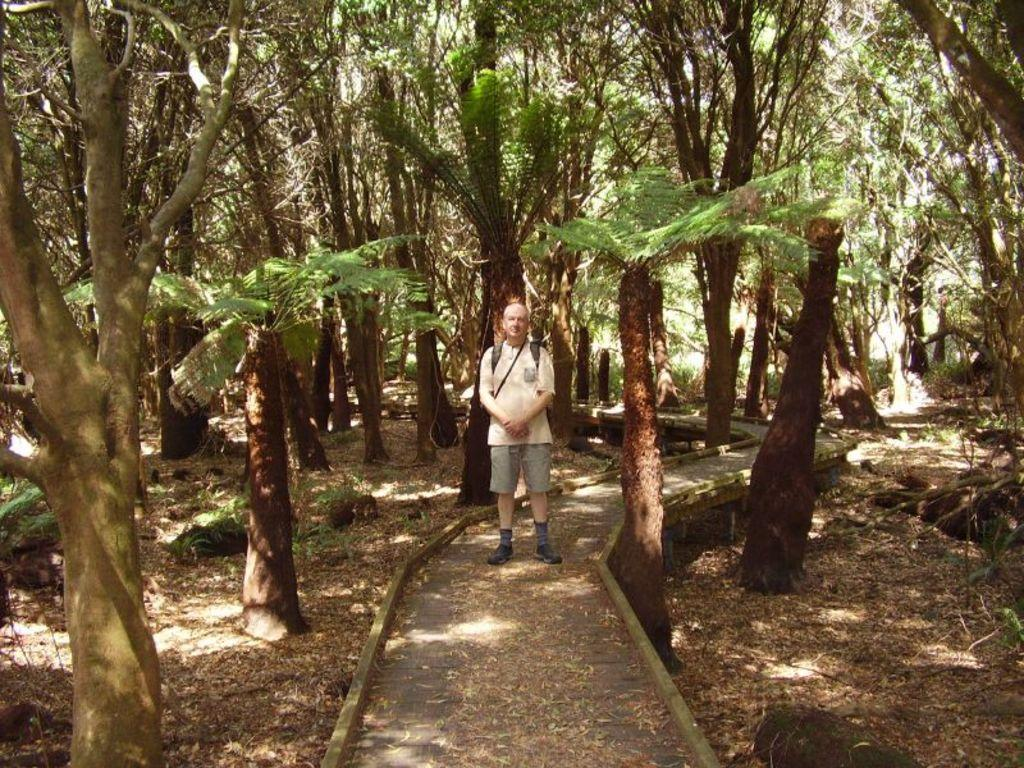Who is the main subject in the image? There is a man standing in the center of the image. Where is the man located in the image? The man is on a walkway. What type of natural environment surrounds the walkway? There are stones, trees, and grass on both the right and left sides of the image. What can be seen in the background of the image? There are trees visible in the background of the image. What type of fuel is being exchanged between the trees in the image? There is no indication of any fuel exchange between the trees in the image; they are simply part of the natural environment. 